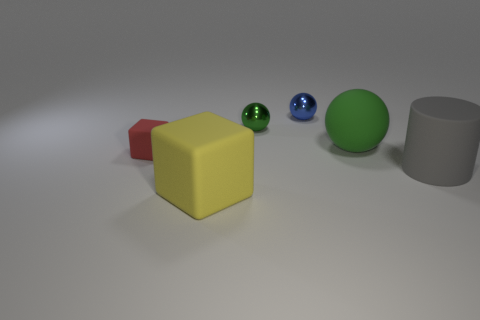What is the size of the other sphere that is the same color as the matte sphere?
Keep it short and to the point. Small. What number of objects are matte objects in front of the red cube or small balls that are in front of the blue metal object?
Offer a very short reply. 3. Are there any large gray matte cylinders behind the tiny red cube?
Your response must be concise. No. What is the color of the cube that is behind the big rubber object that is in front of the matte thing on the right side of the green matte thing?
Keep it short and to the point. Red. Is the tiny red matte thing the same shape as the blue object?
Your answer should be very brief. No. What color is the ball that is the same material as the small green object?
Keep it short and to the point. Blue. How many things are things that are behind the gray cylinder or gray rubber things?
Give a very brief answer. 5. There is a yellow rubber cube that is left of the green shiny sphere; how big is it?
Your response must be concise. Large. There is a cylinder; does it have the same size as the rubber cube on the right side of the tiny red matte block?
Offer a terse response. Yes. What is the color of the large object that is on the left side of the tiny metal sphere on the left side of the small blue metal sphere?
Make the answer very short. Yellow. 